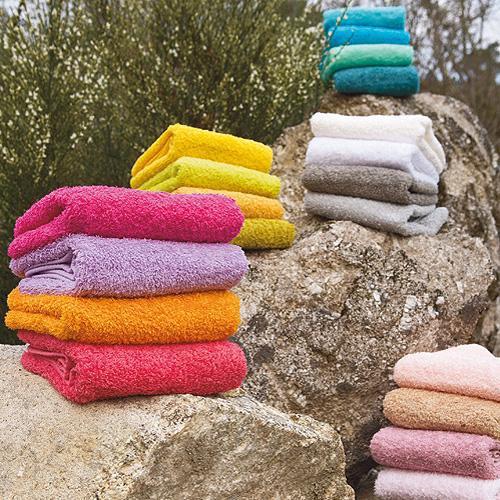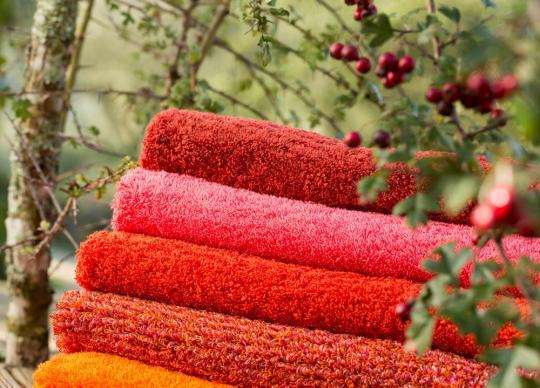The first image is the image on the left, the second image is the image on the right. Examine the images to the left and right. Is the description "There is a least two towers of four towels." accurate? Answer yes or no. Yes. The first image is the image on the left, the second image is the image on the right. Evaluate the accuracy of this statement regarding the images: "There is at least one stack of regularly folded towels in each image, with at least 3 different colors of towel per image.". Is it true? Answer yes or no. Yes. 